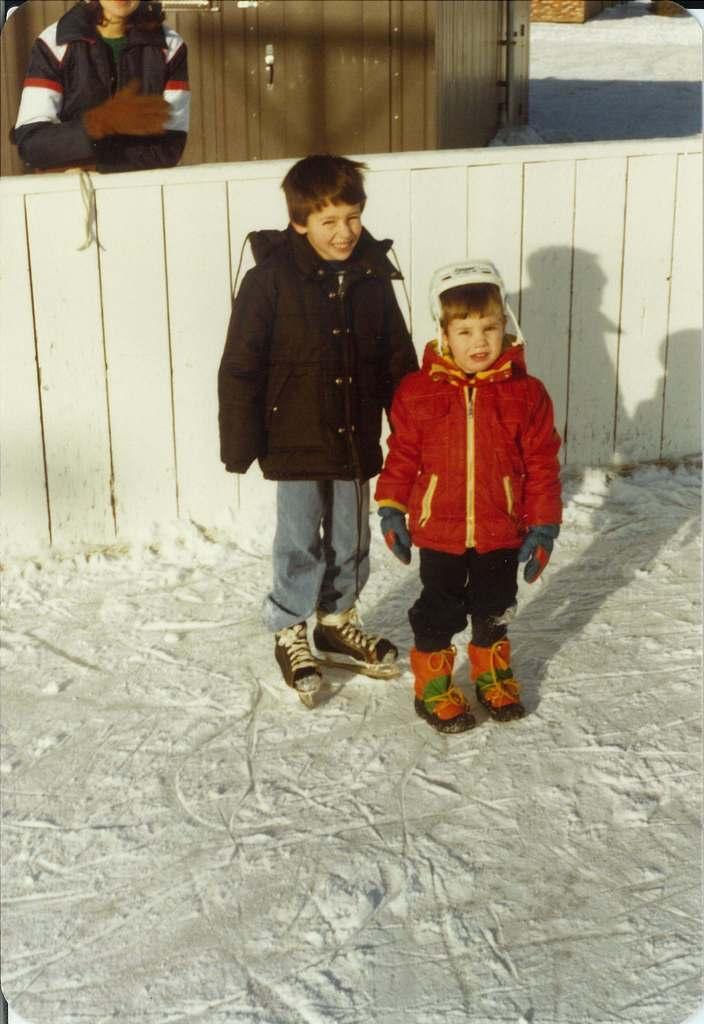Could you give a brief overview of what you see in this image? In this image there are two kids wearing skate shoes standing on the ice surface, behind them there is a wooden fence, behind the wooden fence there is a person, behind the person there is a wooden room. 